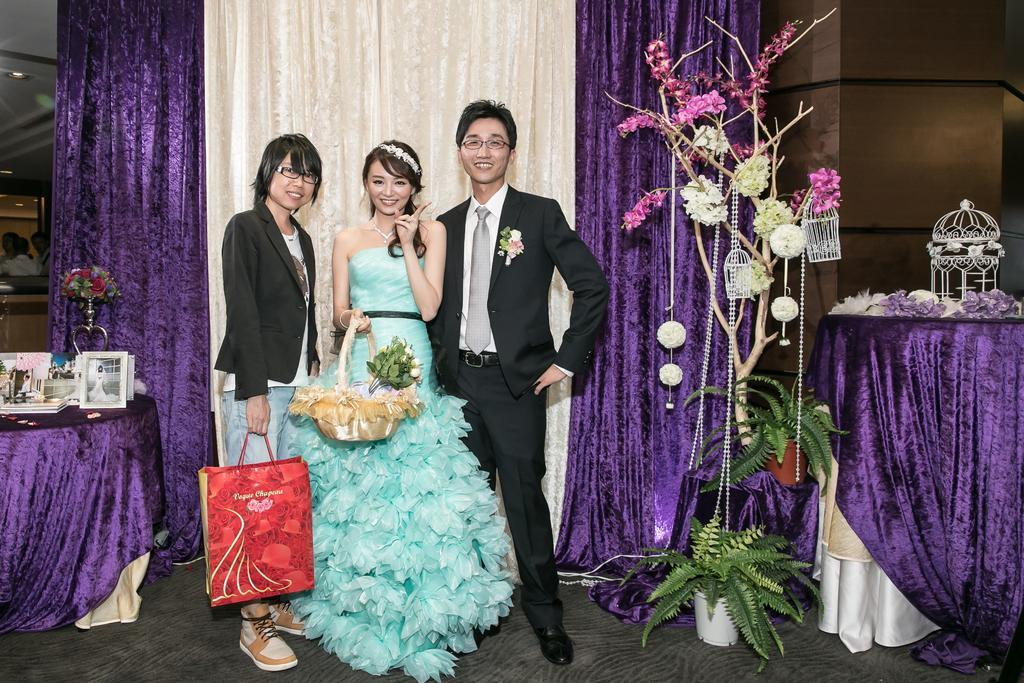Could you give a brief overview of what you see in this image? On the left side of the image I can see curtains, flower bouquet and photo frames. On the right side of the image I can see planets, curtains and trees with flowers. In the middle of the image I can see people are standing and smiling and holding the flower bouquet. 